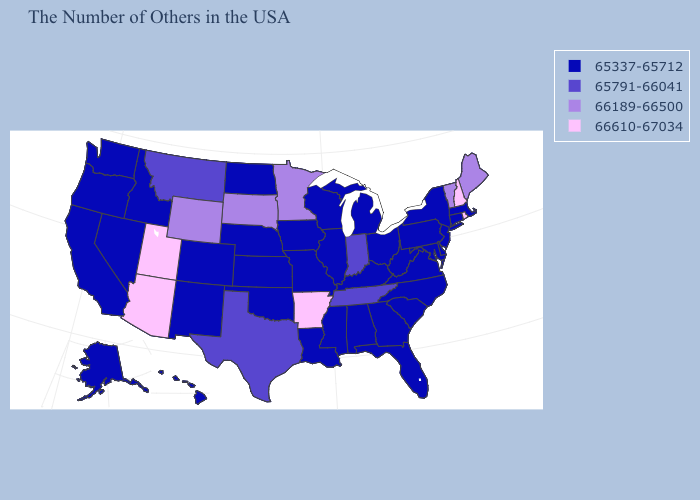Among the states that border California , which have the highest value?
Be succinct. Arizona. Which states have the lowest value in the Northeast?
Short answer required. Massachusetts, Connecticut, New York, New Jersey, Pennsylvania. Which states have the lowest value in the West?
Keep it brief. Colorado, New Mexico, Idaho, Nevada, California, Washington, Oregon, Alaska, Hawaii. What is the value of South Carolina?
Quick response, please. 65337-65712. What is the highest value in states that border Maryland?
Quick response, please. 65337-65712. What is the highest value in the MidWest ?
Concise answer only. 66189-66500. What is the value of Minnesota?
Give a very brief answer. 66189-66500. Name the states that have a value in the range 65791-66041?
Short answer required. Indiana, Tennessee, Texas, Montana. Does the first symbol in the legend represent the smallest category?
Short answer required. Yes. Name the states that have a value in the range 65337-65712?
Answer briefly. Massachusetts, Connecticut, New York, New Jersey, Delaware, Maryland, Pennsylvania, Virginia, North Carolina, South Carolina, West Virginia, Ohio, Florida, Georgia, Michigan, Kentucky, Alabama, Wisconsin, Illinois, Mississippi, Louisiana, Missouri, Iowa, Kansas, Nebraska, Oklahoma, North Dakota, Colorado, New Mexico, Idaho, Nevada, California, Washington, Oregon, Alaska, Hawaii. Which states have the lowest value in the USA?
Quick response, please. Massachusetts, Connecticut, New York, New Jersey, Delaware, Maryland, Pennsylvania, Virginia, North Carolina, South Carolina, West Virginia, Ohio, Florida, Georgia, Michigan, Kentucky, Alabama, Wisconsin, Illinois, Mississippi, Louisiana, Missouri, Iowa, Kansas, Nebraska, Oklahoma, North Dakota, Colorado, New Mexico, Idaho, Nevada, California, Washington, Oregon, Alaska, Hawaii. What is the highest value in states that border New Mexico?
Keep it brief. 66610-67034. Does the first symbol in the legend represent the smallest category?
Give a very brief answer. Yes. What is the lowest value in the USA?
Write a very short answer. 65337-65712. Does the map have missing data?
Short answer required. No. 